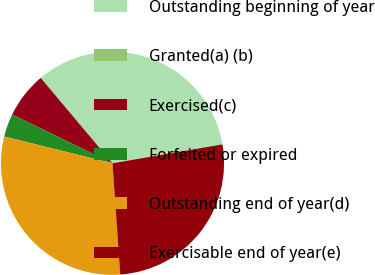Convert chart to OTSL. <chart><loc_0><loc_0><loc_500><loc_500><pie_chart><fcel>Outstanding beginning of year<fcel>Granted(a) (b)<fcel>Exercised(c)<fcel>Forfeited or expired<fcel>Outstanding end of year(d)<fcel>Exercisable end of year(e)<nl><fcel>33.41%<fcel>0.0%<fcel>6.68%<fcel>3.34%<fcel>29.95%<fcel>26.61%<nl></chart> 